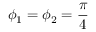<formula> <loc_0><loc_0><loc_500><loc_500>\phi _ { 1 } = \phi _ { 2 } = \frac { \pi } { 4 }</formula> 